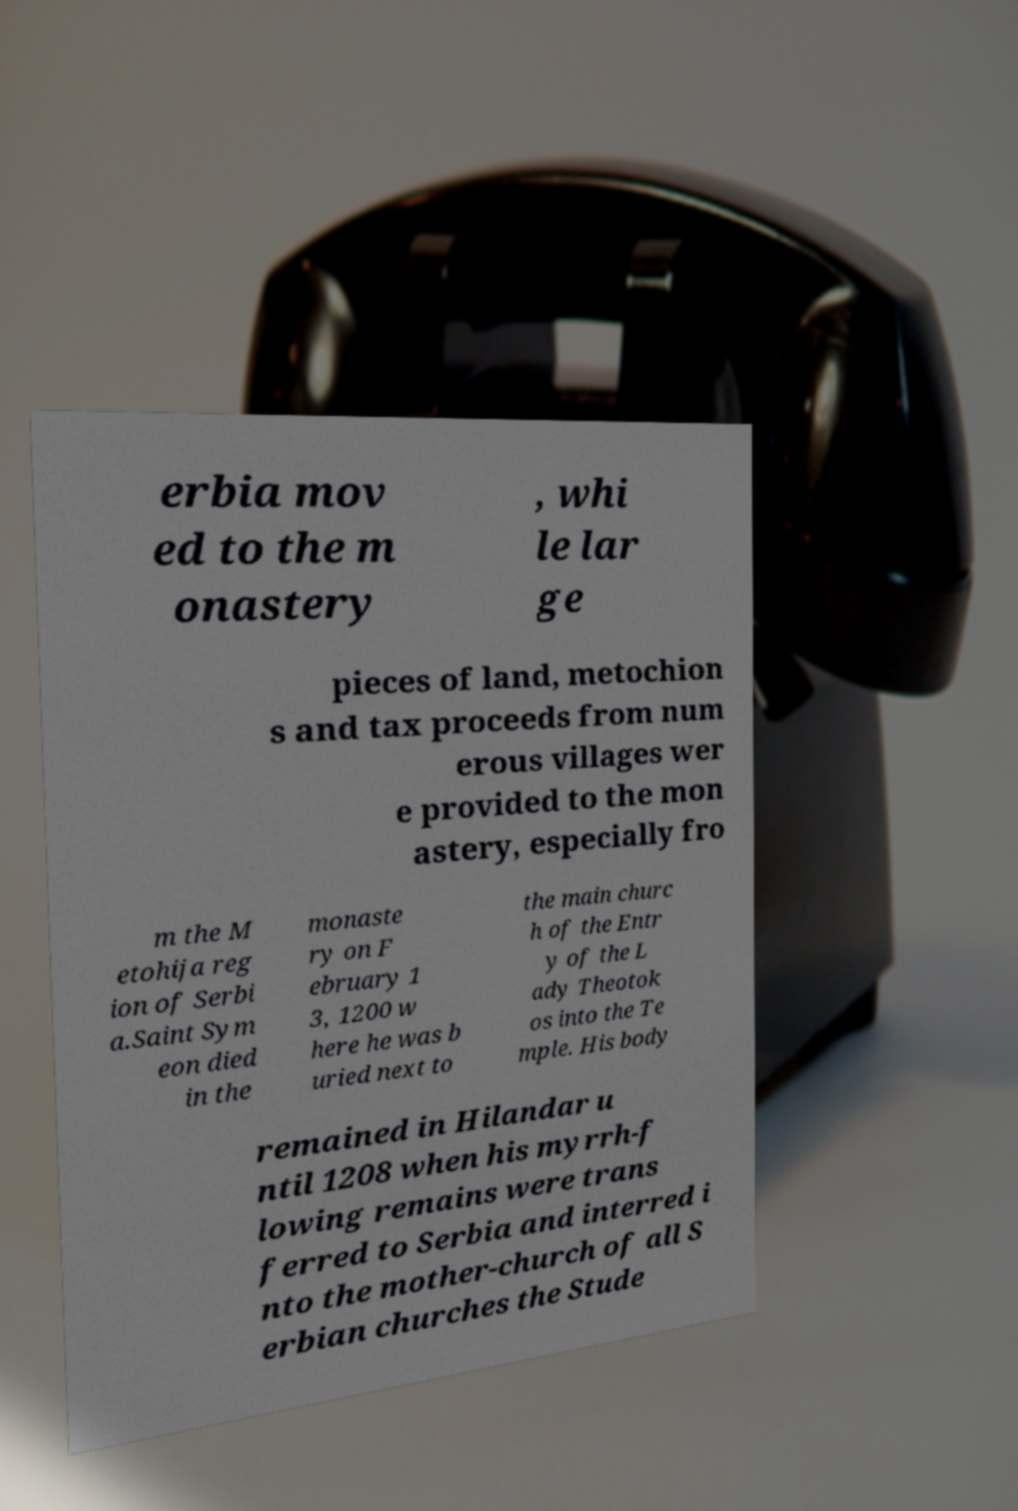I need the written content from this picture converted into text. Can you do that? erbia mov ed to the m onastery , whi le lar ge pieces of land, metochion s and tax proceeds from num erous villages wer e provided to the mon astery, especially fro m the M etohija reg ion of Serbi a.Saint Sym eon died in the monaste ry on F ebruary 1 3, 1200 w here he was b uried next to the main churc h of the Entr y of the L ady Theotok os into the Te mple. His body remained in Hilandar u ntil 1208 when his myrrh-f lowing remains were trans ferred to Serbia and interred i nto the mother-church of all S erbian churches the Stude 